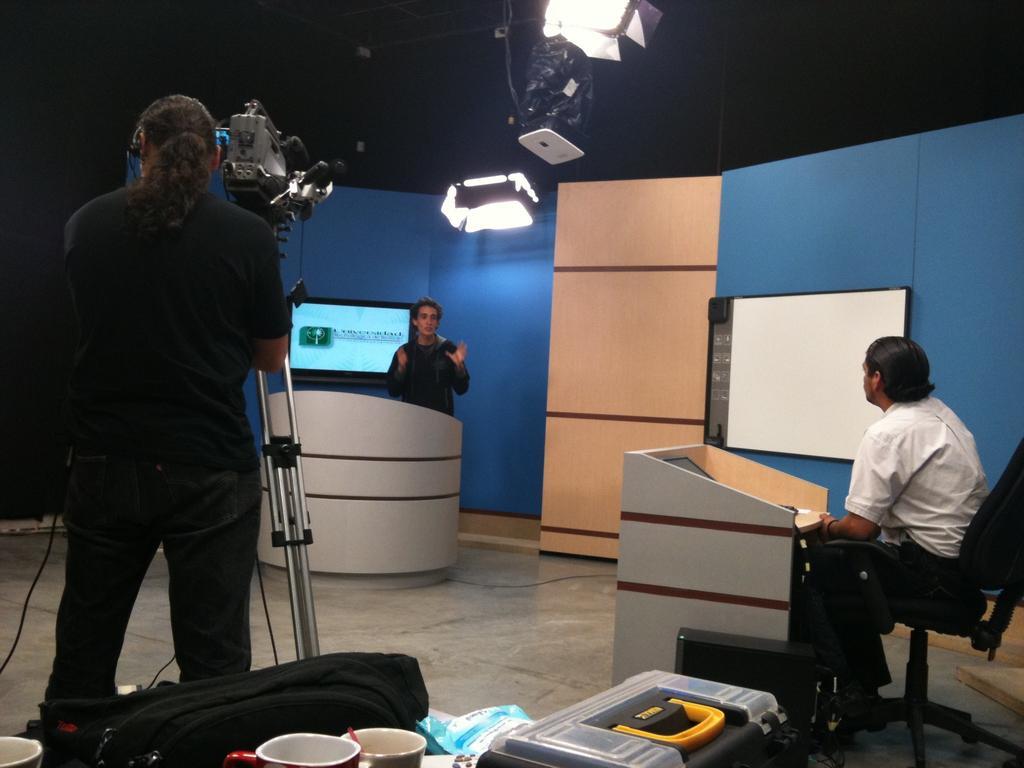Can you describe this image briefly? In this image, we can see people and one of them is sitting on the chair and there is a person wearing headset. In the background, there are lights and we can see a camera stand, a podium and some screens on the wall and there is a stand and we can see a bag, cup, a box and some other objects. At the bottom, there is a floor. 